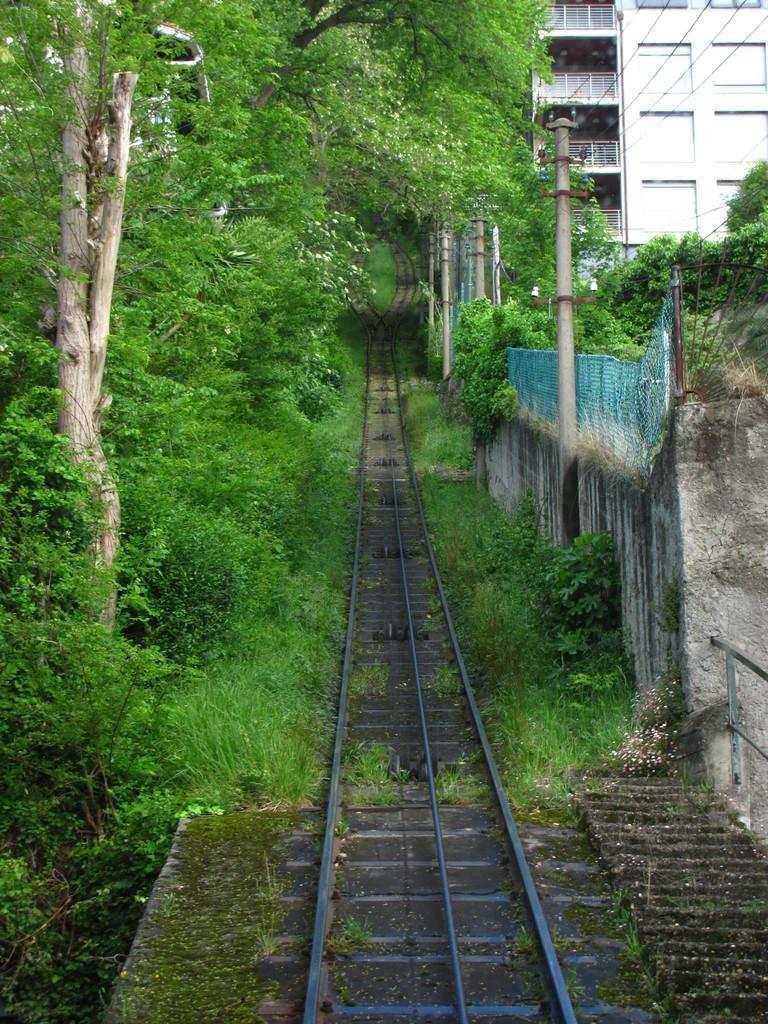Can you describe this image briefly? In this image I can see few railway tracks in the centre and both side of it I can see grass and number of trees. On the right side of this image I can see few poles, few wires and a building. 